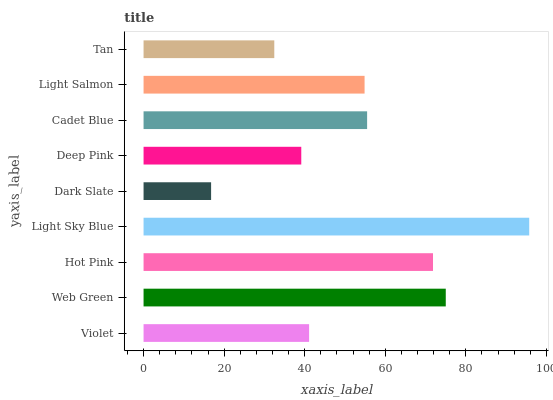Is Dark Slate the minimum?
Answer yes or no. Yes. Is Light Sky Blue the maximum?
Answer yes or no. Yes. Is Web Green the minimum?
Answer yes or no. No. Is Web Green the maximum?
Answer yes or no. No. Is Web Green greater than Violet?
Answer yes or no. Yes. Is Violet less than Web Green?
Answer yes or no. Yes. Is Violet greater than Web Green?
Answer yes or no. No. Is Web Green less than Violet?
Answer yes or no. No. Is Light Salmon the high median?
Answer yes or no. Yes. Is Light Salmon the low median?
Answer yes or no. Yes. Is Deep Pink the high median?
Answer yes or no. No. Is Dark Slate the low median?
Answer yes or no. No. 